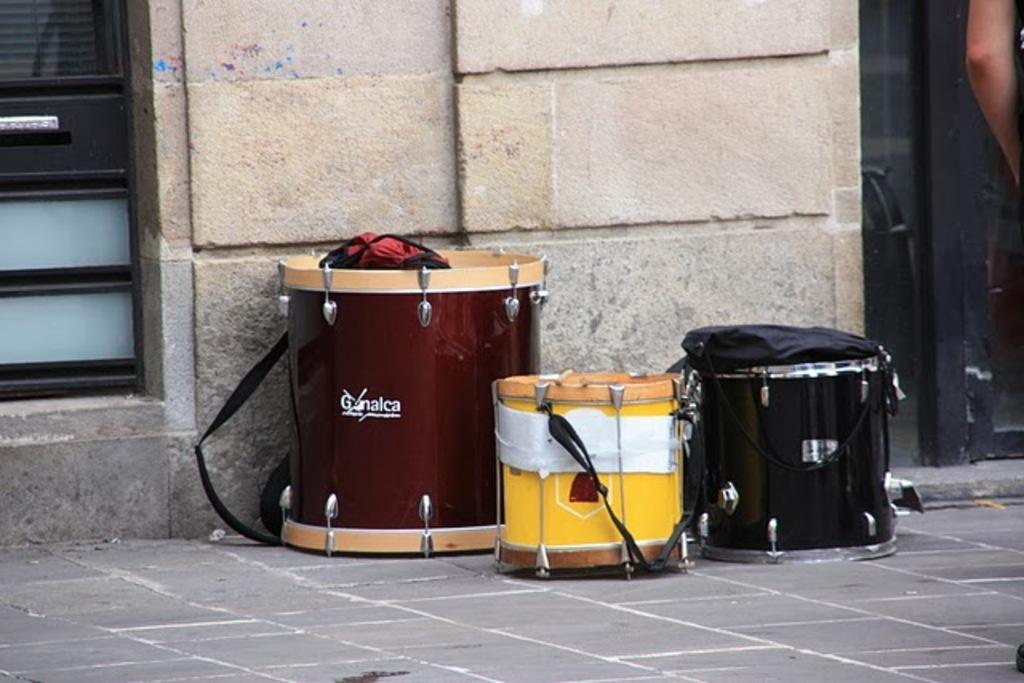How would you summarize this image in a sentence or two? In this picture we can see musical drums and bags. On the left and right side of the image we can see doors which are truncated. There is a wall. 